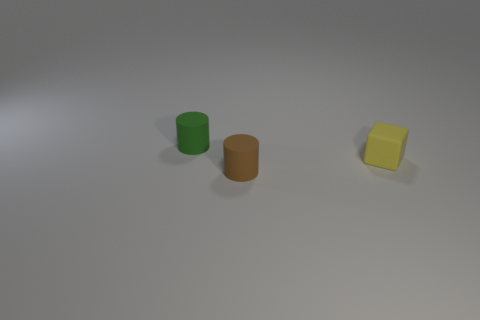Are there fewer yellow rubber objects that are behind the tiny yellow cube than small matte cylinders that are in front of the tiny green object?
Keep it short and to the point. Yes. What number of things are either tiny objects that are to the left of the brown thing or brown things?
Offer a terse response. 2. There is a tiny rubber cylinder that is left of the rubber cylinder in front of the yellow rubber object; how many tiny matte cylinders are behind it?
Your answer should be compact. 0. What number of cylinders are either small green rubber things or brown matte things?
Your response must be concise. 2. The cylinder that is behind the small matte cylinder that is on the right side of the cylinder that is on the left side of the tiny brown object is what color?
Provide a short and direct response. Green. How many other things are the same size as the matte block?
Provide a short and direct response. 2. Are there any other things that are the same shape as the yellow object?
Your response must be concise. No. There is another tiny rubber thing that is the same shape as the green thing; what is its color?
Provide a short and direct response. Brown. What color is the small cylinder that is the same material as the tiny brown thing?
Make the answer very short. Green. Are there the same number of green cylinders that are to the left of the tiny green rubber cylinder and brown metal blocks?
Ensure brevity in your answer.  Yes. 